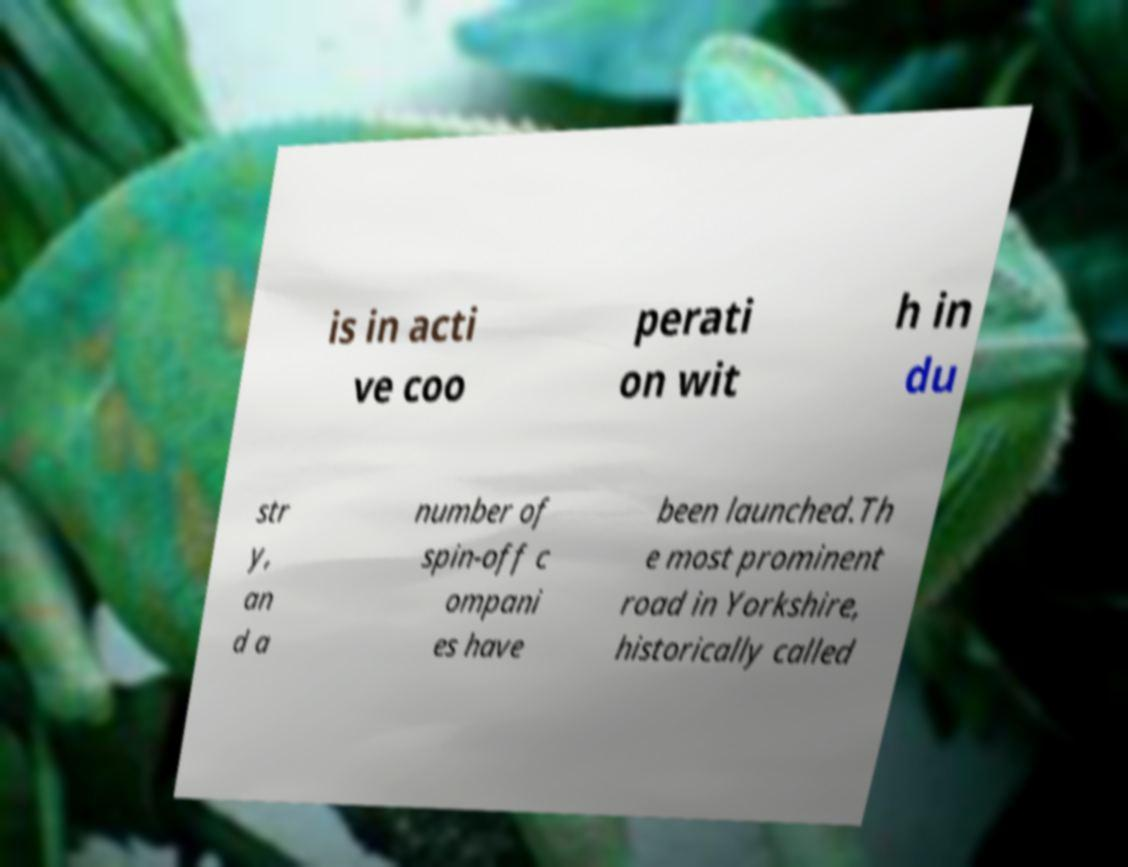Could you extract and type out the text from this image? is in acti ve coo perati on wit h in du str y, an d a number of spin-off c ompani es have been launched.Th e most prominent road in Yorkshire, historically called 